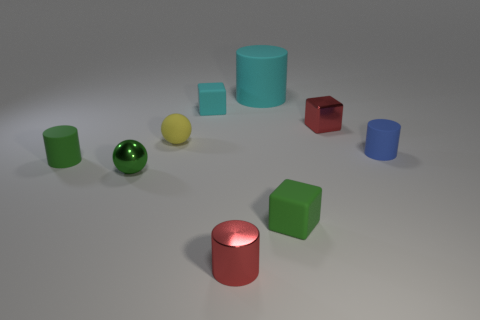Can you describe the overall arrangement and variety of shapes visible in this image? Certainly! The image showcases a collection of geometric solids evenly spaced on a neutral surface. We observe three cylinders, one of which is notably larger and has a matte finish, along with three spheres, which are glossy and reflective. Additionally, there are three cubes with varying colors, contributing to the diversity of forms and textures in the scene. 